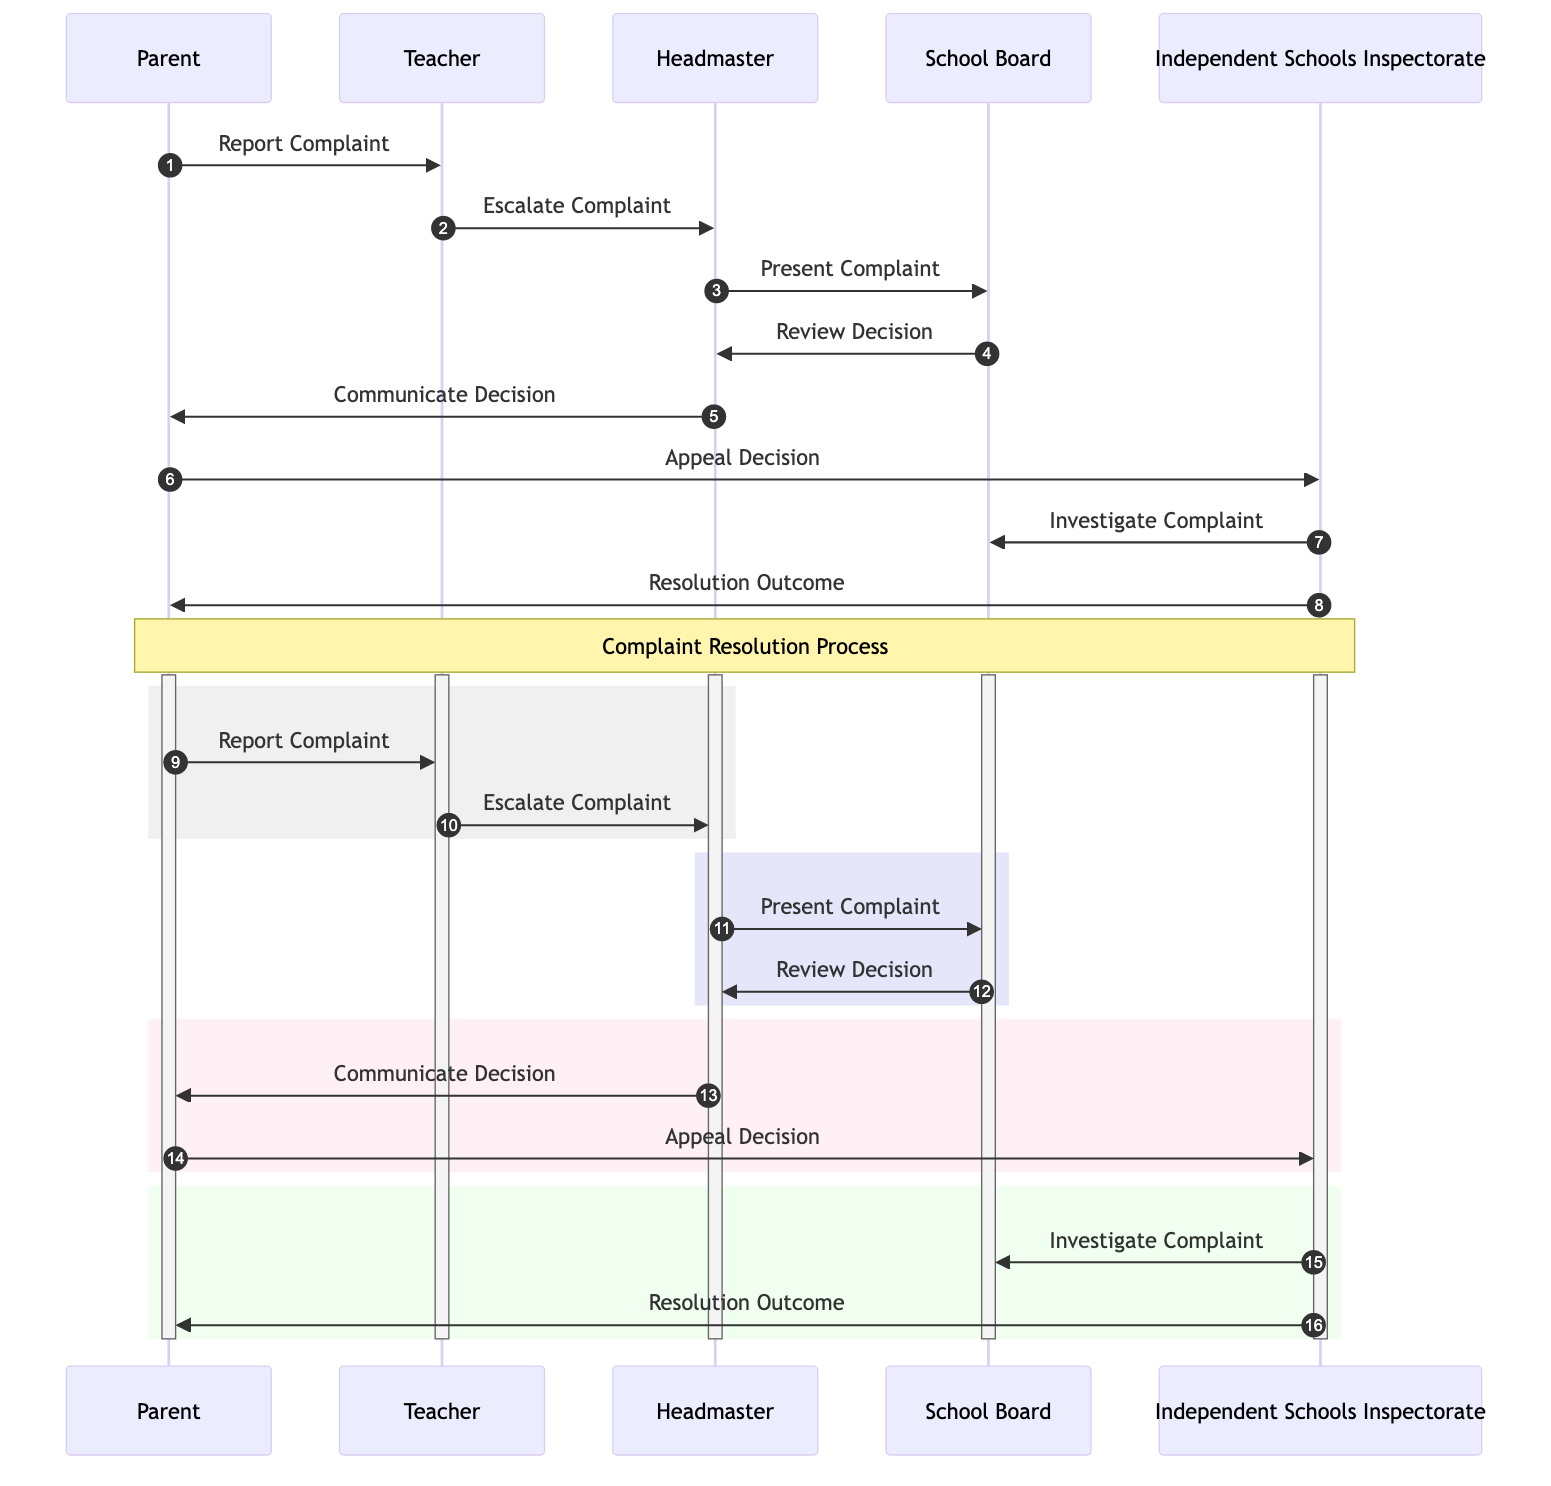What is the first action taken in the complaint process? The first action is taken by the Parent who reports the complaint to the Teacher. This is indicated by the arrow from Parent to Teacher labeled "Report Complaint."
Answer: Report Complaint Who presents the complaint to the School Board? The Headmaster presents the complaint to the School Board, as shown by the arrow from Headmaster to School Board with the message "Present Complaint."
Answer: Headmaster How many actors are involved in this sequence diagram? The actors include five distinct roles: Parent, Teacher, Headmaster, School Board, and Independent Schools Inspectorate. This can be counted from the list of participants in the diagram.
Answer: Five What is the outcome communicated to the Parent after the School Board reviews the decision? The outcome communicated to the Parent is captured by the Headmaster's message, which states "Communicate Decision." The sequence clearly indicates this step following the review decision.
Answer: Communicate Decision What action does the Parent take if they are not satisfied with the decision? If the Parent is not satisfied with the decision, they will appeal to the Independent Schools Inspectorate, as indicated by the message "Appeal Decision" from Parent to Independent Schools Inspectorate.
Answer: Appeal Decision What does the Independent Schools Inspectorate do after receiving the Parent's appeal? The Independent Schools Inspectorate investigates the complaint, which is denoted by the message "Investigate Complaint" sent to the School Board.
Answer: Investigate Complaint What is the final action taken in this complaint resolution process? The final action taken is the Independent Schools Inspectorate providing the "Resolution Outcome" to the Parent, demonstrating the closure of the complaint process.
Answer: Resolution Outcome How many messages are exchanged between the Headmaster and the School Board? There are two messages exchanged: "Present Complaint" and "Review Decision," indicating the two points of communication between these two actors.
Answer: Two What does the message flow from the Independent Schools Inspectorate to the Parent signify? The message flow from the Independent Schools Inspectorate to the Parent, labeled "Resolution Outcome," signifies the conclusion of the complaint process with the final decision communicated to the Parent.
Answer: Resolution Outcome 